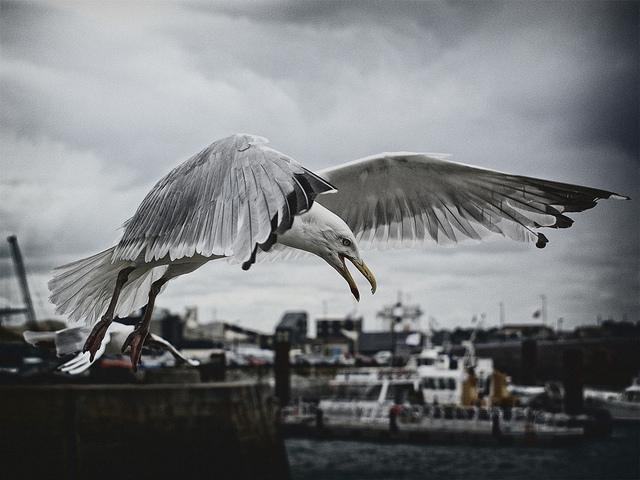How many boats are visible?
Give a very brief answer. 2. How many doors on the bus are closed?
Give a very brief answer. 0. 